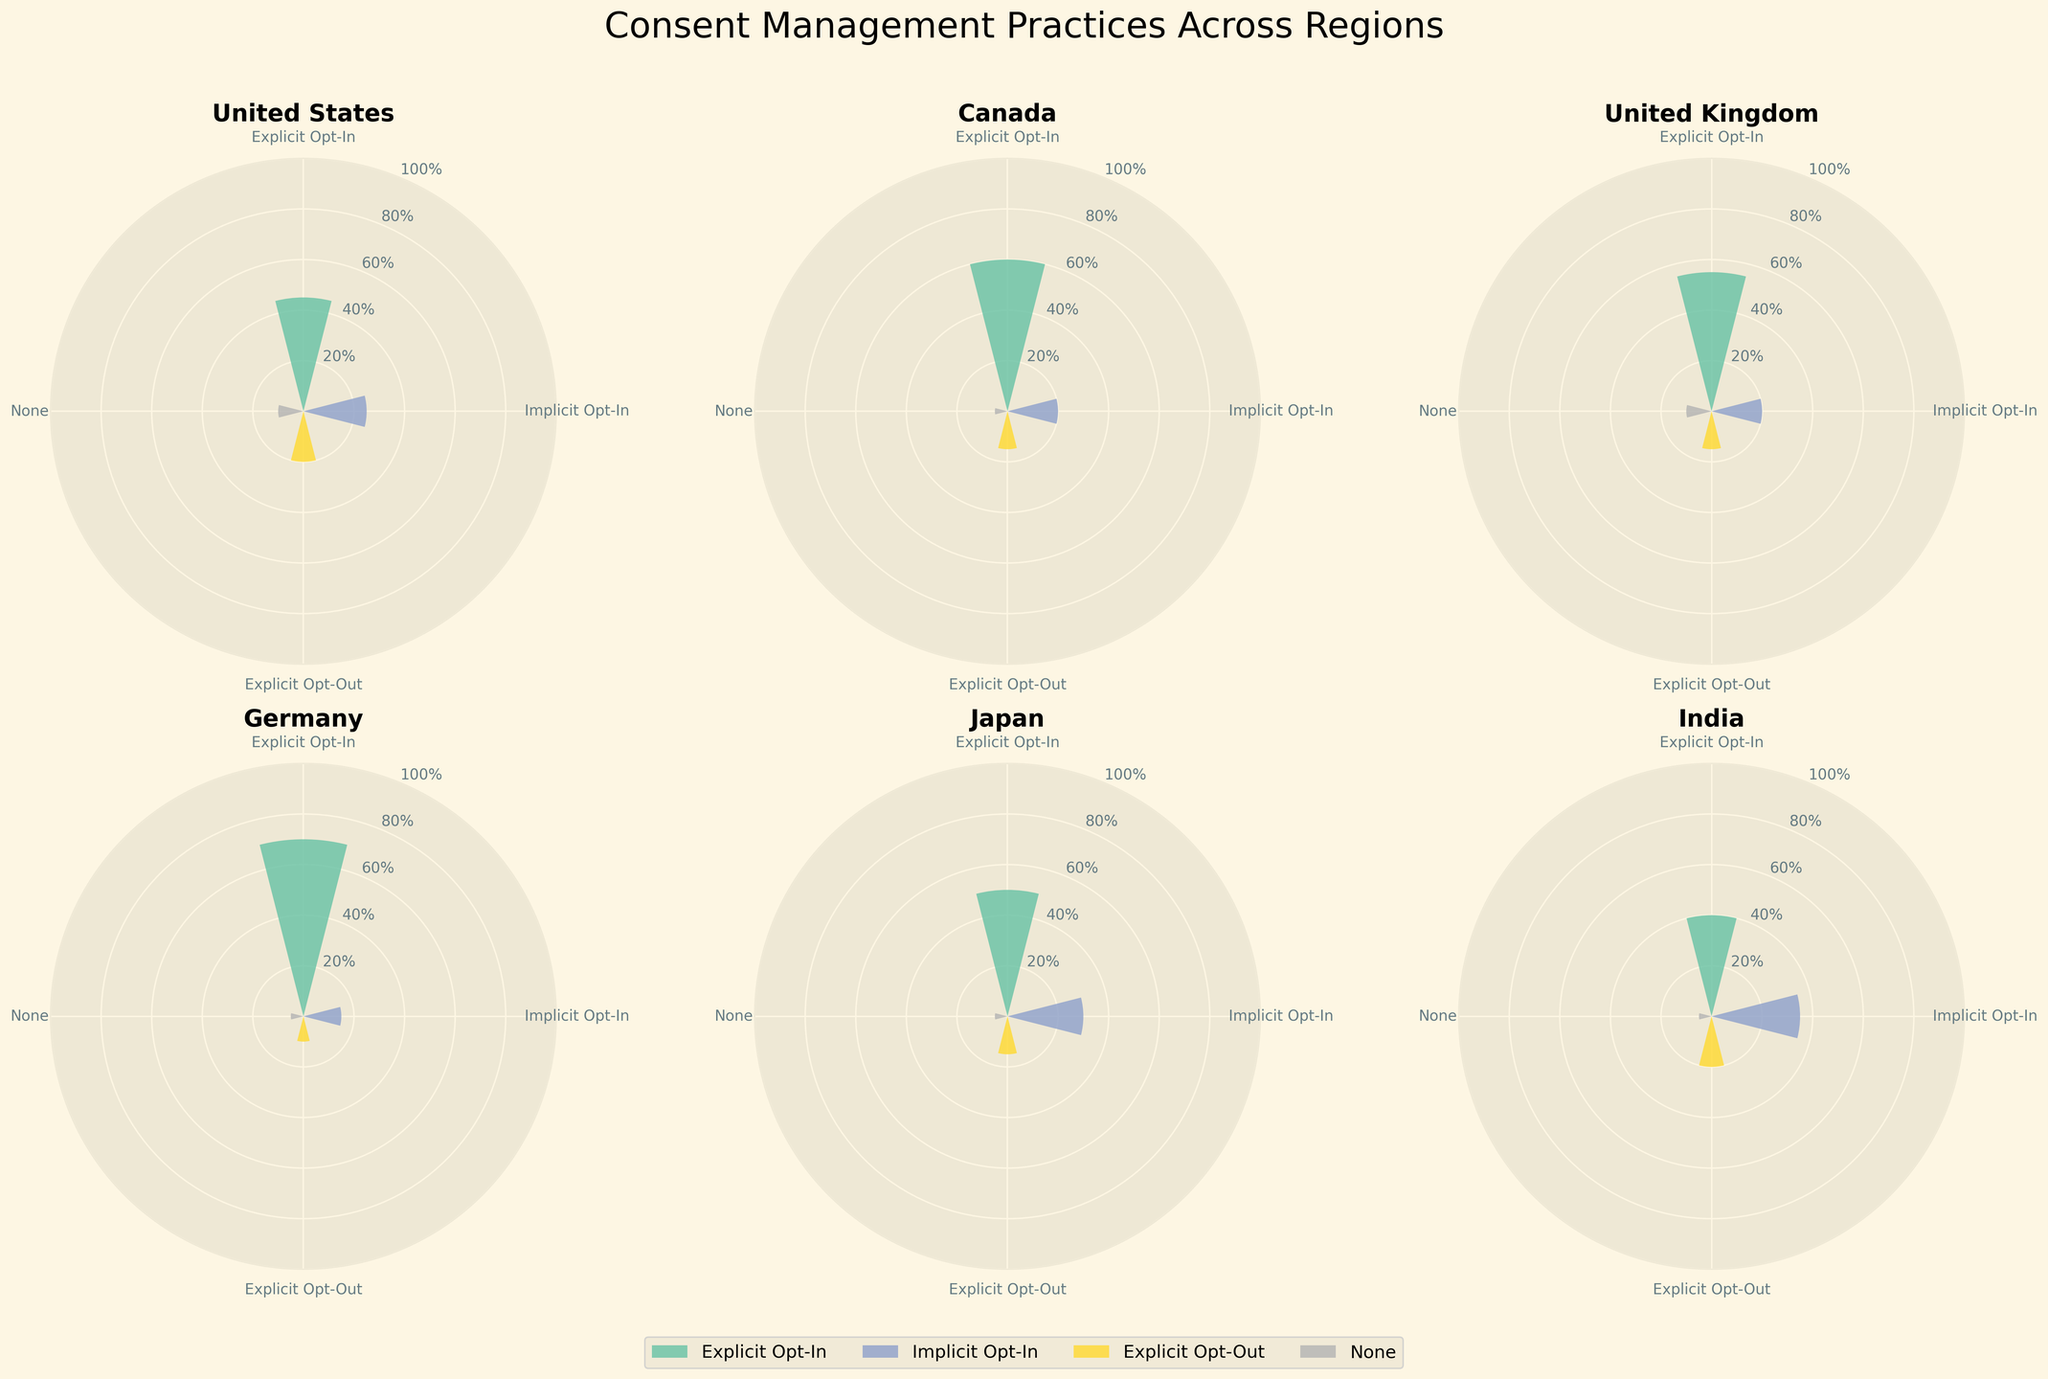What is the most common consent mechanism in the United States? By observing the United States plot, the sector with the largest area is Explicit Opt-In, showing it has the highest percentage.
Answer: Explicit Opt-In Which country has the lowest percentage of 'None' as a consent mechanism? Look at the sectors labeled 'None' across different countries and identify the smallest percentage. Both Canada and Germany show 5%, which are the lowest.
Answer: Canada and Germany How do Explicit Opt-In percentages compare between Germany and Japan? Refer to the rose charts for both Germany and Japan. Germany shows 70% for Explicit Opt-In, whereas Japan shows 50%. Compare these percentages.
Answer: Germany has a higher percentage What is the combined percentage of Implicit Opt-In and Explicit Opt-Out in Canada? From Canada's chart, Implicit Opt-In is 20% and Explicit Opt-Out is 15%. Add these two percentages together: 20 + 15 = 35%.
Answer: 35% Among the regions shown, which country has the highest Explicit Opt-In percentage? Review the rose charts for all countries. Germany has the highest percentage for Explicit Opt-In at 70%.
Answer: Germany What is the title of the figure? The title of the figure is located at the top and reads "Consent Management Practices Across Regions".
Answer: Consent Management Practices Across Regions Which country has the smallest Explicit Opt-Out percentage? Compare the Explicit Opt-Out percentages of all countries. Germany shows the smallest value at 10%.
Answer: Germany How many different consent mechanisms are represented in each country? Each rose chart has sectors for 4 different consent mechanisms: Explicit Opt-In, Implicit Opt-In, Explicit Opt-Out, and None.
Answer: 4 In the United Kingdom, what is the difference in percentage between Explicit Opt-In and Implicit Opt-In? In the United Kingdom's chart, Explicit Opt-In is 55% and Implicit Opt-In is 20%. The difference is 55 - 20 = 35%.
Answer: 35% How does the combined percentage of 'None' across all countries compare to the combined percentage of Explicit Opt-Out in the United States? Add the 'None' percentages for all countries: 10 (US) + 5 (Canada) + 10 (UK) + 5 (Germany) + 5 (Japan) + 5 (India) = 40%. Explicit Opt-Out in the US is 20%. Compare these values.
Answer: Combined 'None' is higher 